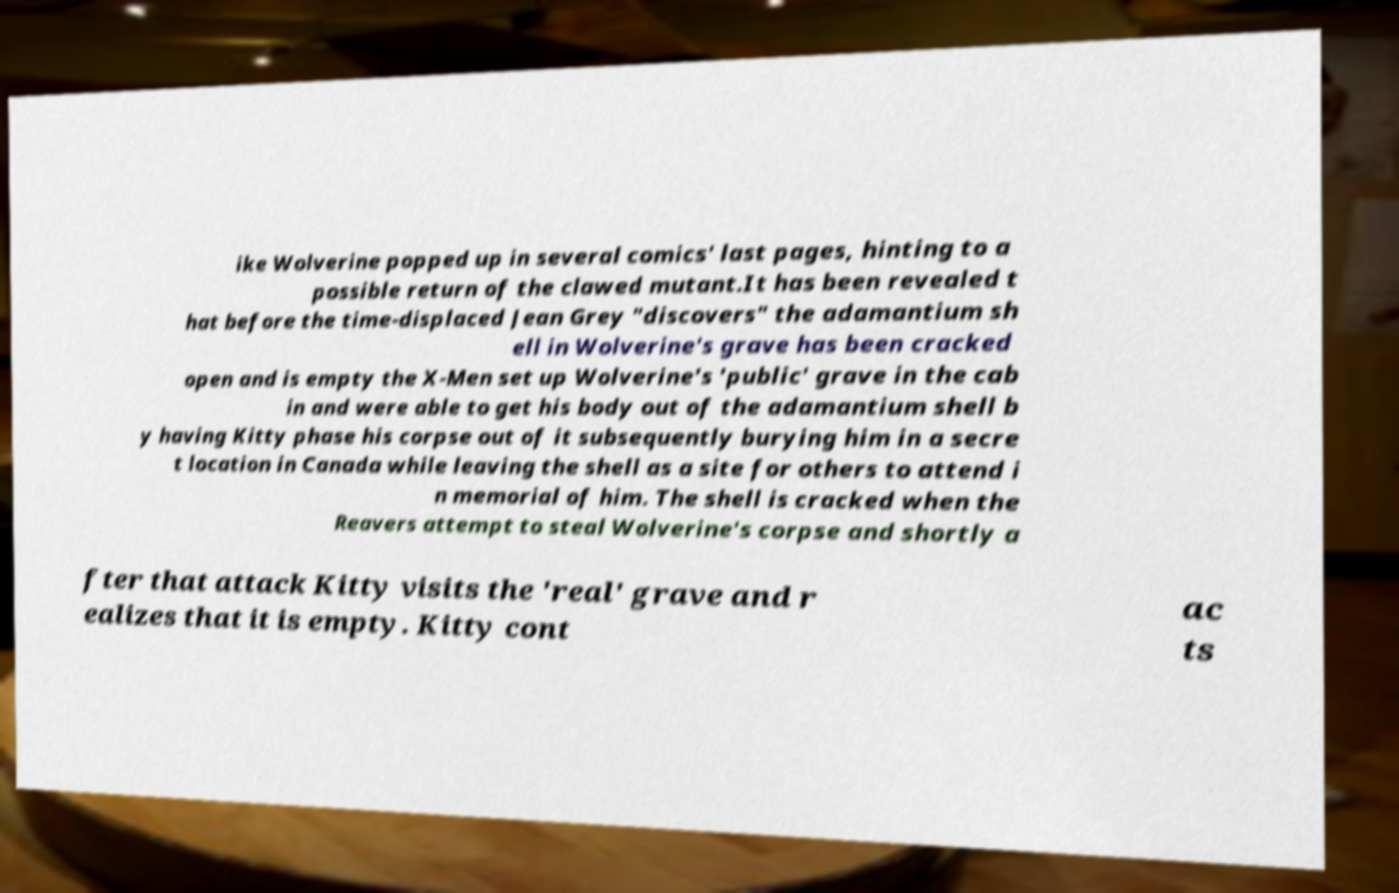What messages or text are displayed in this image? I need them in a readable, typed format. ike Wolverine popped up in several comics' last pages, hinting to a possible return of the clawed mutant.It has been revealed t hat before the time-displaced Jean Grey "discovers" the adamantium sh ell in Wolverine's grave has been cracked open and is empty the X-Men set up Wolverine's 'public' grave in the cab in and were able to get his body out of the adamantium shell b y having Kitty phase his corpse out of it subsequently burying him in a secre t location in Canada while leaving the shell as a site for others to attend i n memorial of him. The shell is cracked when the Reavers attempt to steal Wolverine's corpse and shortly a fter that attack Kitty visits the 'real' grave and r ealizes that it is empty. Kitty cont ac ts 